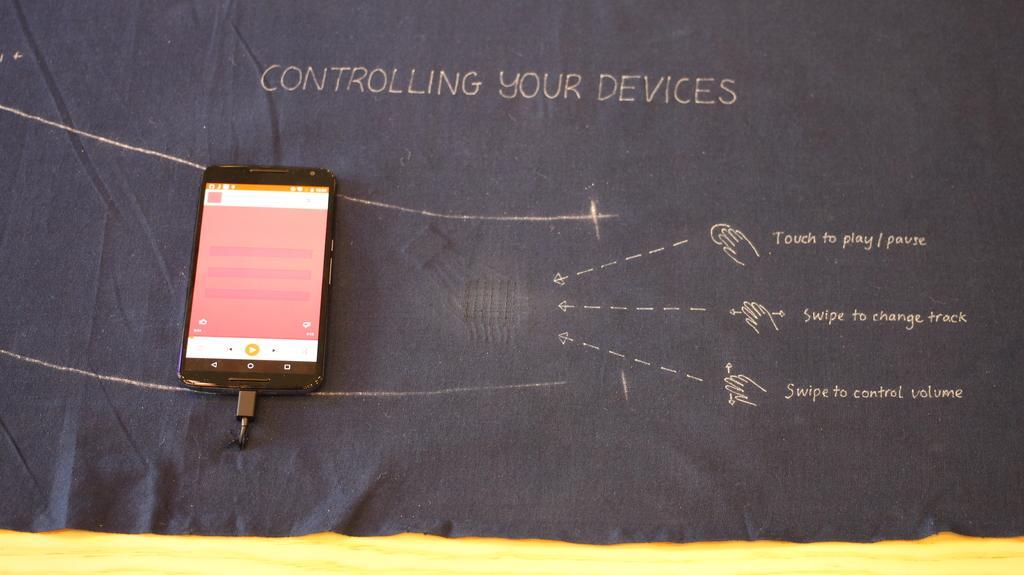<image>
Share a concise interpretation of the image provided. phone laying on black paper display showing instructions for controlling your devices 